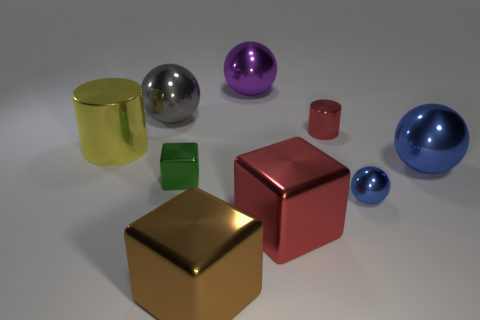Subtract all big metallic balls. How many balls are left? 1 Add 1 metal cylinders. How many objects exist? 10 Subtract all red cylinders. How many cylinders are left? 1 Subtract 1 cylinders. How many cylinders are left? 1 Subtract all cylinders. How many objects are left? 7 Subtract all brown cylinders. How many red balls are left? 0 Subtract all large purple spheres. Subtract all large purple shiny balls. How many objects are left? 7 Add 9 red cubes. How many red cubes are left? 10 Add 8 tiny blocks. How many tiny blocks exist? 9 Subtract 0 yellow spheres. How many objects are left? 9 